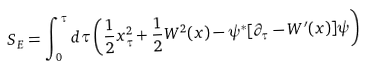<formula> <loc_0><loc_0><loc_500><loc_500>S _ { E } = \int _ { 0 } ^ { \tau } d \tau \left ( { \frac { 1 } { 2 } } x _ { \tau } ^ { 2 } + { \frac { 1 } { 2 } } W ^ { 2 } ( x ) - \psi ^ { \ast } [ \partial _ { \tau } - W ^ { \prime } ( x ) ] \psi \right )</formula> 